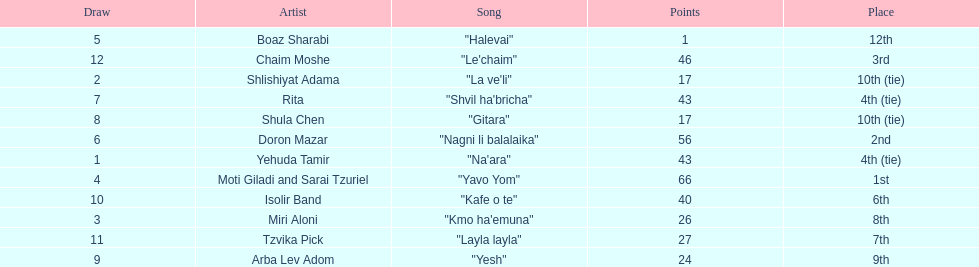What is the name of the first song listed on this chart? "Na'ara". 